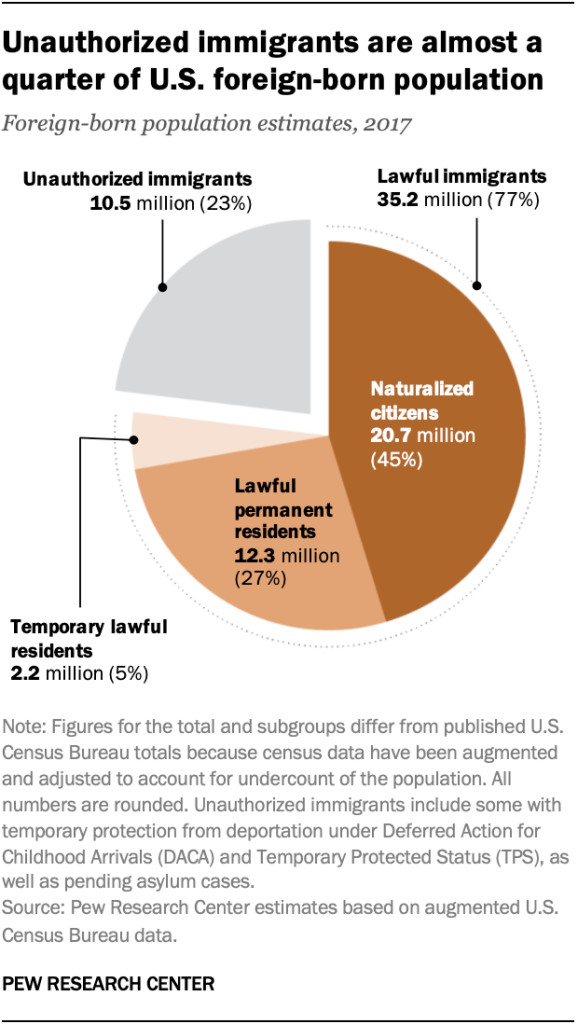Point out several critical features in this image. In 2017, the estimated population of unauthorized immigrants was approximately 10.5 million people. The total population of naturalized citizens and lawful permanent residents in the United States' foreign-born population is approximately 33%. 